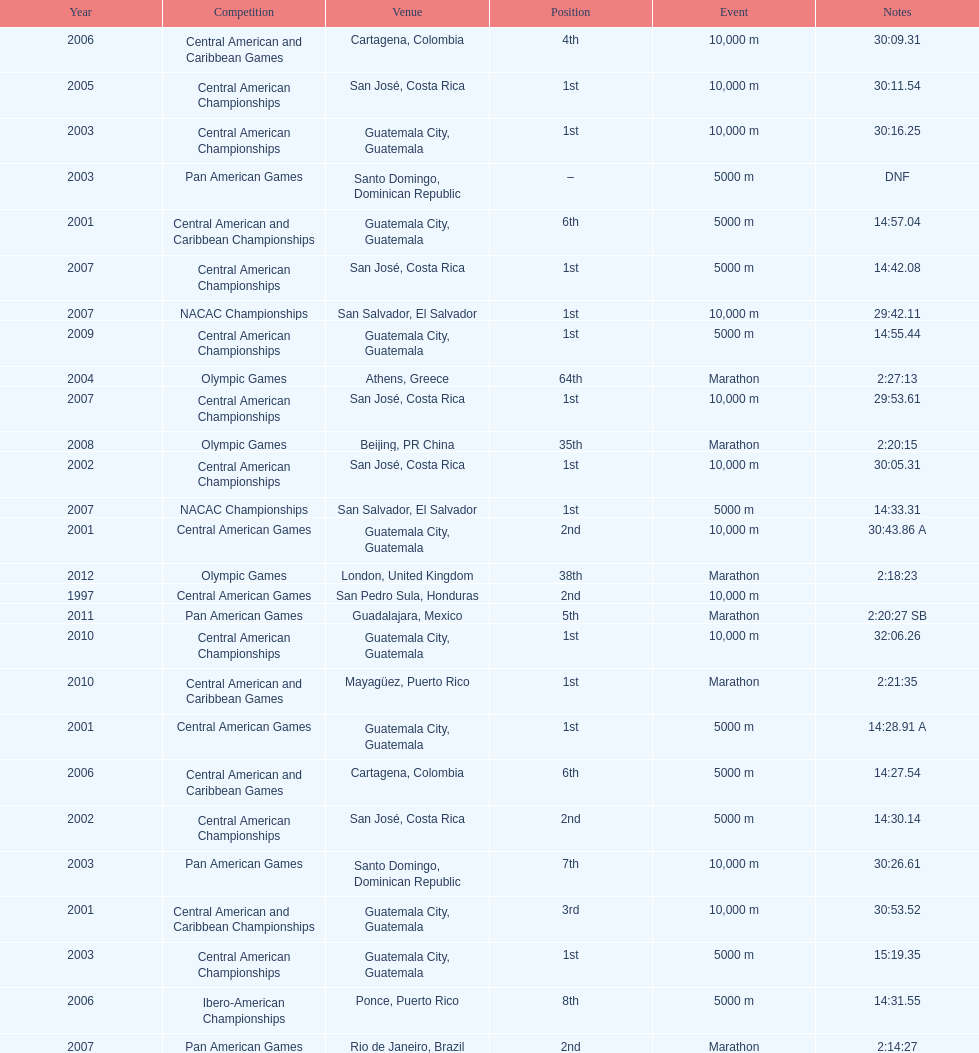What competition did this competitor compete at after participating in the central american games in 2001? Central American Championships. 